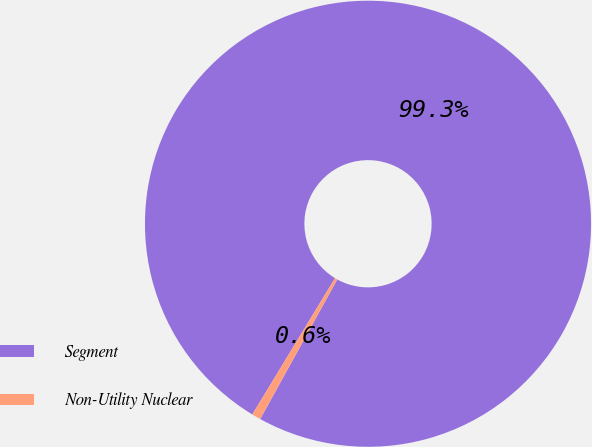Convert chart. <chart><loc_0><loc_0><loc_500><loc_500><pie_chart><fcel>Segment<fcel>Non-Utility Nuclear<nl><fcel>99.35%<fcel>0.65%<nl></chart> 